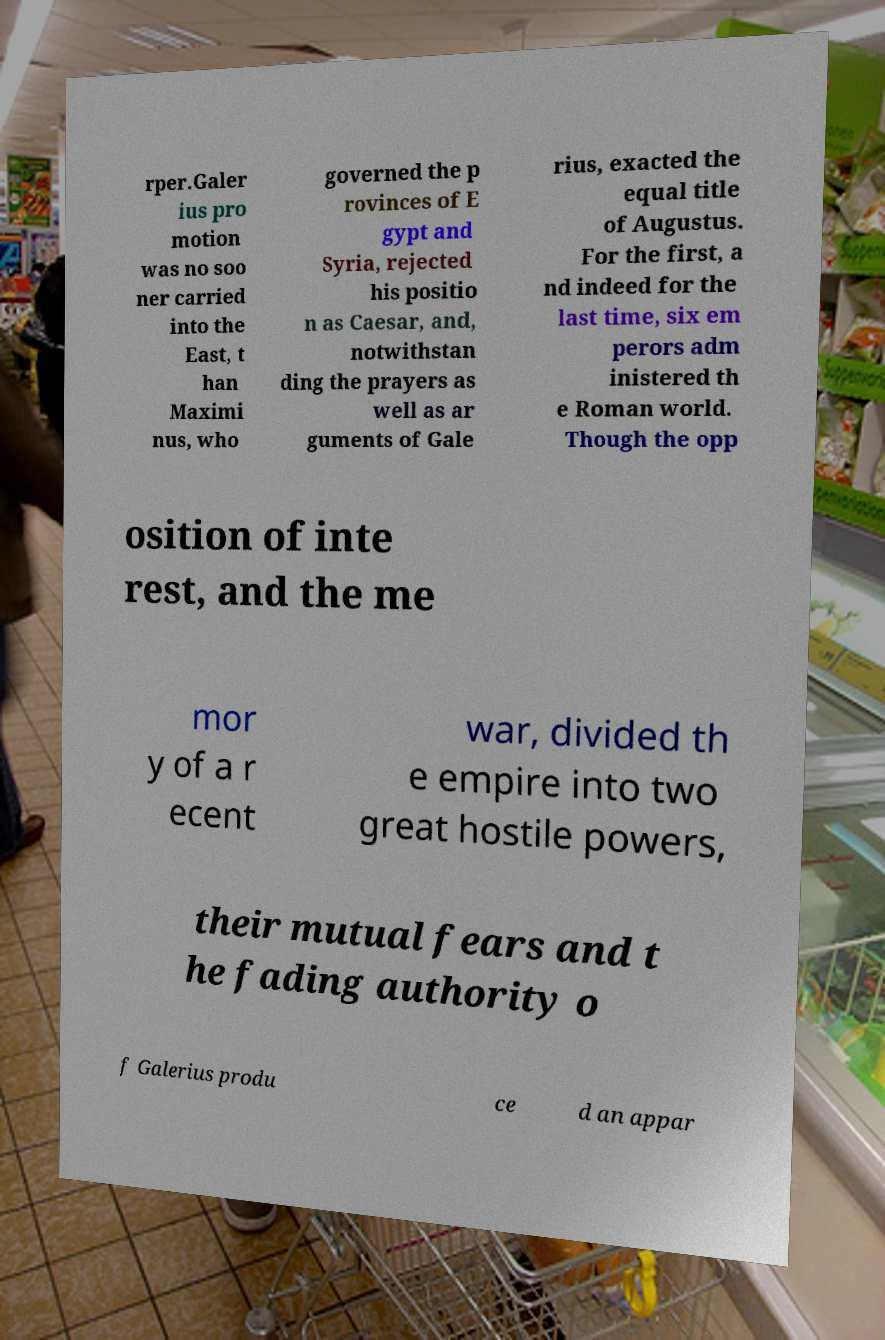Could you extract and type out the text from this image? rper.Galer ius pro motion was no soo ner carried into the East, t han Maximi nus, who governed the p rovinces of E gypt and Syria, rejected his positio n as Caesar, and, notwithstan ding the prayers as well as ar guments of Gale rius, exacted the equal title of Augustus. For the first, a nd indeed for the last time, six em perors adm inistered th e Roman world. Though the opp osition of inte rest, and the me mor y of a r ecent war, divided th e empire into two great hostile powers, their mutual fears and t he fading authority o f Galerius produ ce d an appar 